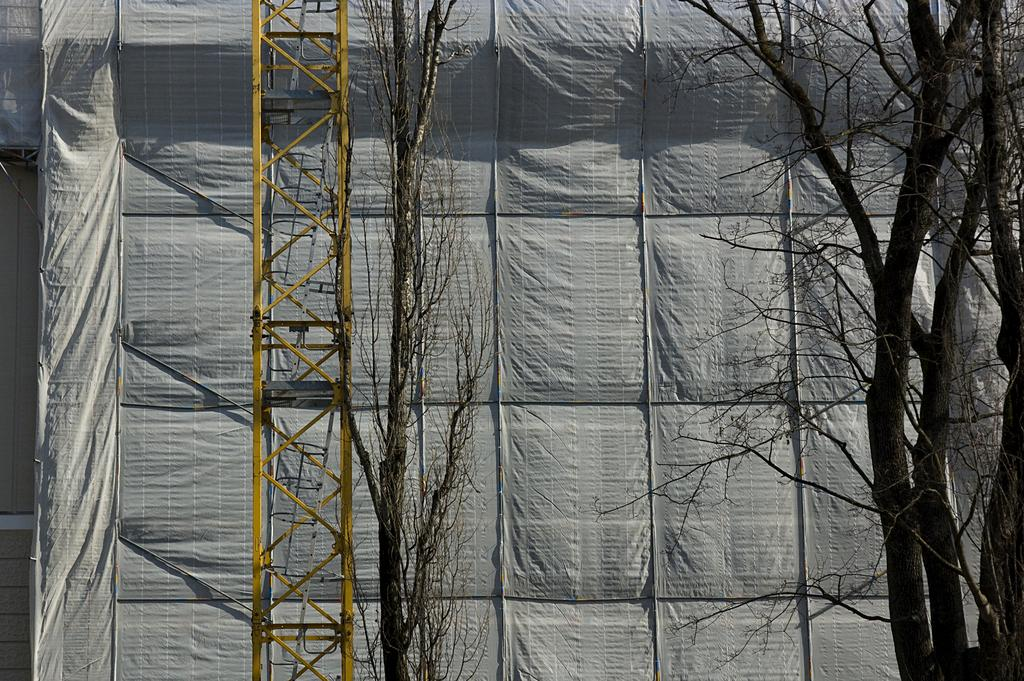What is located in the foreground of the image? There are trees in the foreground of the image. What is visible in the background of the image? There is a cover in the background of the image. What type of structure can be seen in the image? There is a tower in the image. What type of stem can be seen growing from the trees in the image? There is no stem growing from the trees in the image; only the trees themselves are visible. Is there any blood visible on the tower in the image? There is no blood present in the image; the tower appears to be undamaged. 